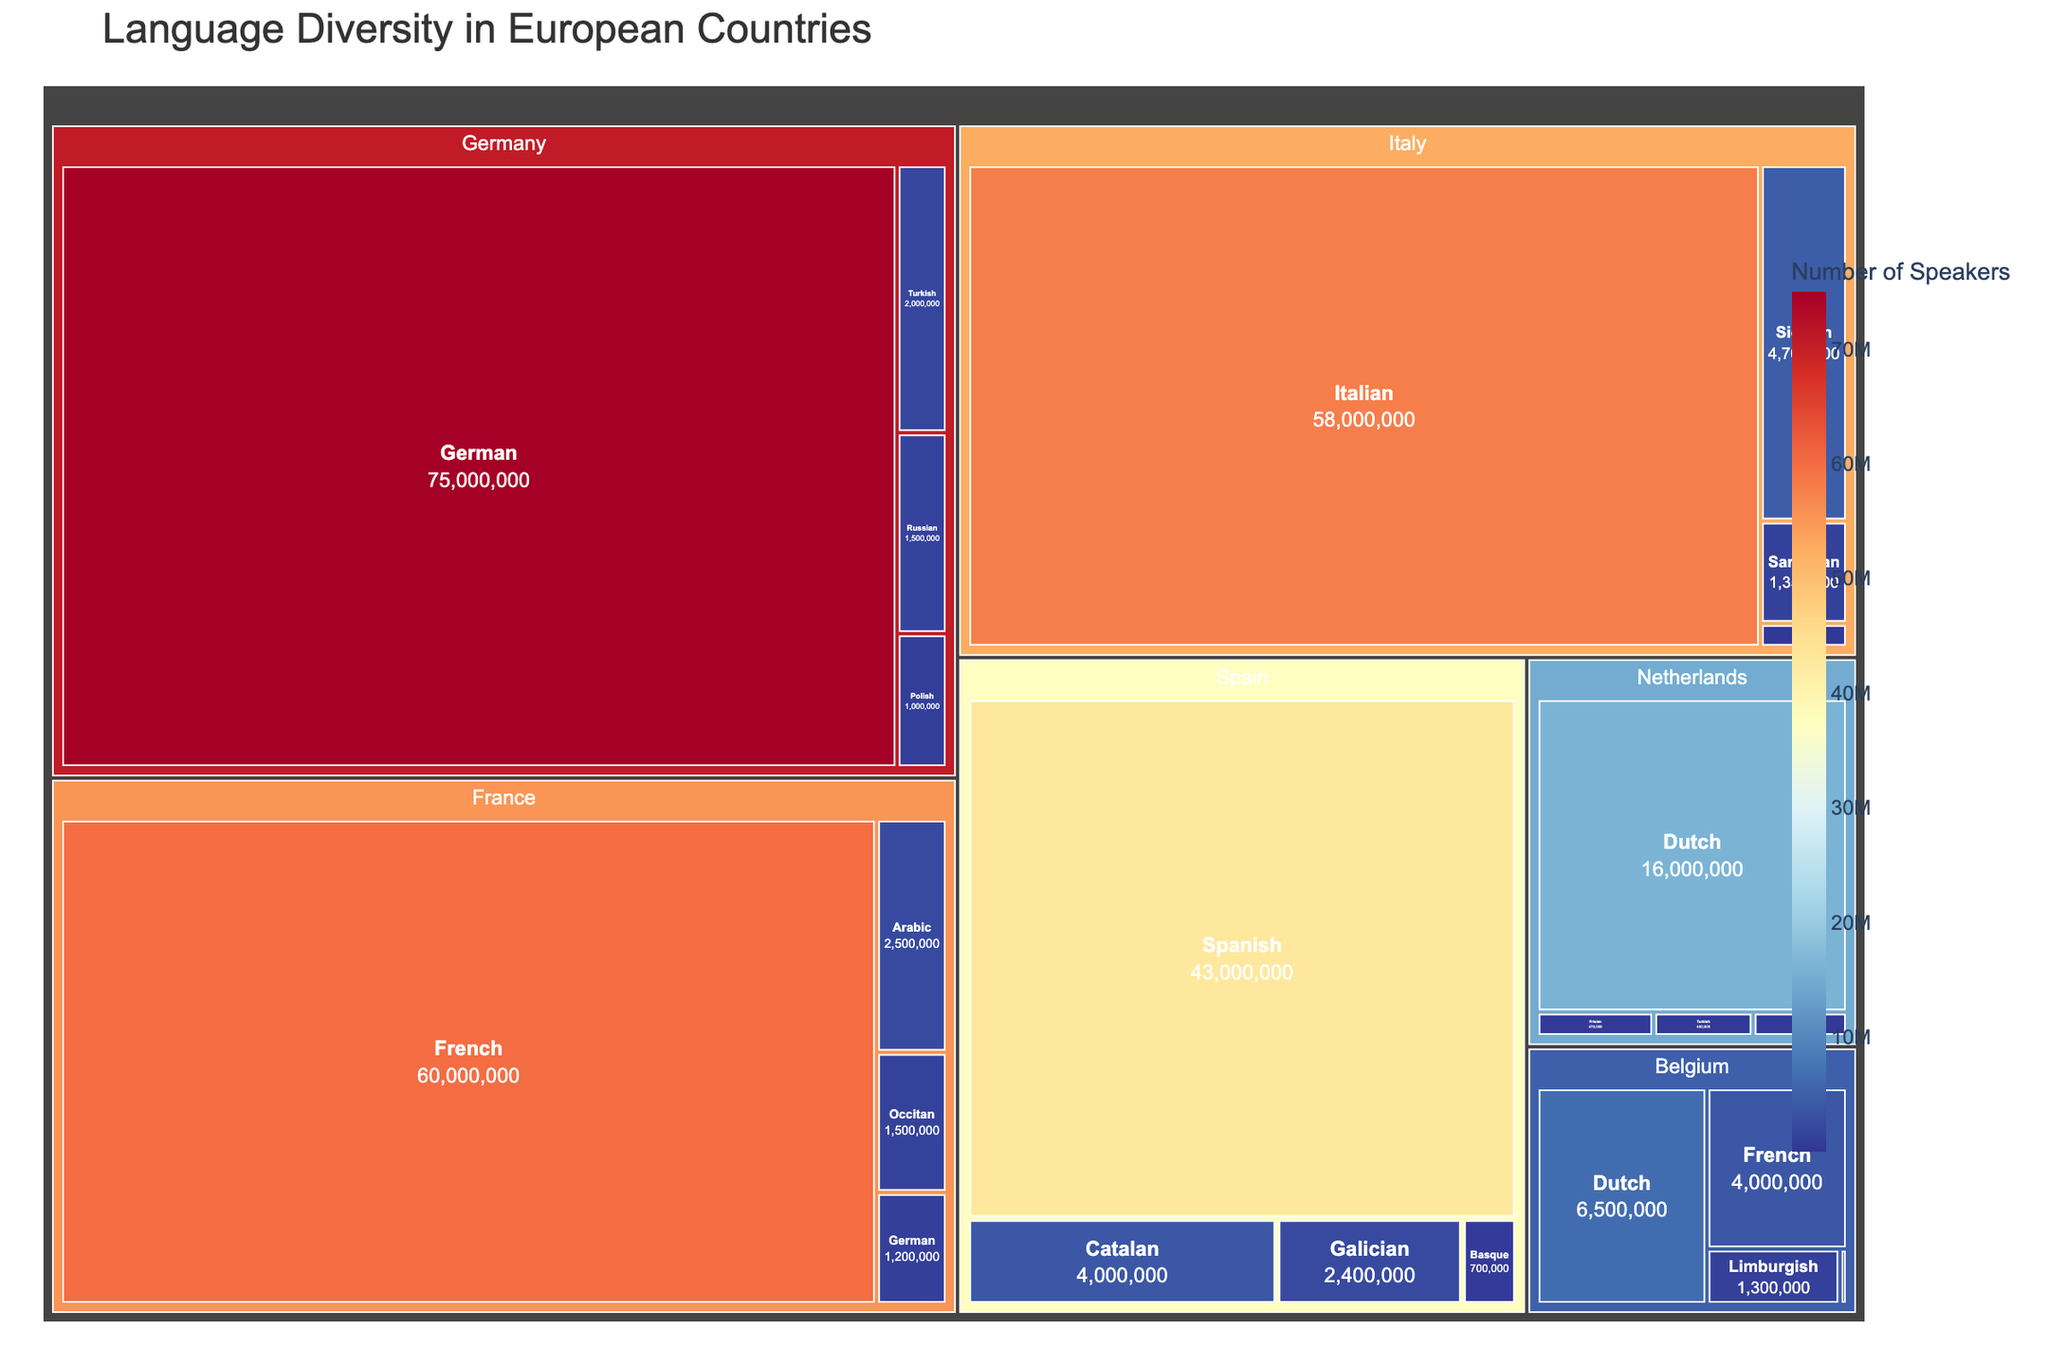What's the title of the figure? The title is usually prominently displayed at the top of the figure. In this case, the title is 'Language Diversity in European Countries'.
Answer: Language Diversity in European Countries Which country has the highest number of speakers for a single language? From the figure, you can identify the largest tile under each country. Germany has the largest tile for German with 75,000,000 speakers.
Answer: Germany How many speakers speak French in Belgium compared to France? Find the tile for French under Belgium and France and compare the values. Belgium has 4,000,000 speakers of French, while France has 60,000,000 speakers of French.
Answer: Belgium: 4,000,000, France: 60,000,000 Which countries have German as a spoken language and how many speakers are there in each? Locate the tiles for German under each country. Germany has 75,000,000 speakers, France has 1,200,000 speakers, Italy has 315,000 speakers, and Belgium has 73,000 speakers.
Answer: Germany: 75,000,000, France: 1,200,000, Italy: 315,000, Belgium: 73,000 What is the total number of Turkish speakers across all countries? Locate the Turkish tiles under each country and sum the values. Germany has 2,000,000 speakers, and the Netherlands have 400,000 speakers. Summing these gives 2,000,000 + 400,000 = 2,400,000
Answer: 2,400,000 Which language has the fewest speakers in the Netherlands, and how many speakers does it have? Look at the tiles under the Netherlands and find the one with the smallest value. Frisian has the fewest speakers with 470,000.
Answer: Frisian, 470,000 Compare the number of speakers of Catalan in Spain to Sicilian in Italy. Which is more, and by how much? Find the tiles for Catalan in Spain and Sicilian in Italy. Spain has 4,000,000 speakers of Catalan, Italy has 4,700,000 speakers of Sicilian. Subtract the smaller number from the larger: 4,700,000 - 4,000,000 = 700,000
Answer: Sicilian by 700,000 Which country has the greatest language diversity in terms of the number of different languages spoken? Observe the number of distinct language tiles within each country. France has the most diversity with 4 different languages: French, Arabic, Occitan, German.
Answer: France Compare the combined number of speakers of Galician and Basque in Spain to the number of speakers of Italian in Italy. Which is higher and by how much? Sum the number of speakers of Galician and Basque: 2,400,000 (Galician) + 700,000 (Basque) = 3,100,000. Compare this to the number of speakers of Italian in Italy, which is 58,000,000. The difference is 58,000,000 - 3,100,000 = 54,900,000
Answer: Italian by 54,900,000 What is the total number of speakers for the French language across all European countries listed? Sum the number of speakers for French in each country. France has 60,000,000 and Belgium has 4,000,000. Total is 60,000,000 + 4,000,000 = 64,000,000
Answer: 64,000,000 